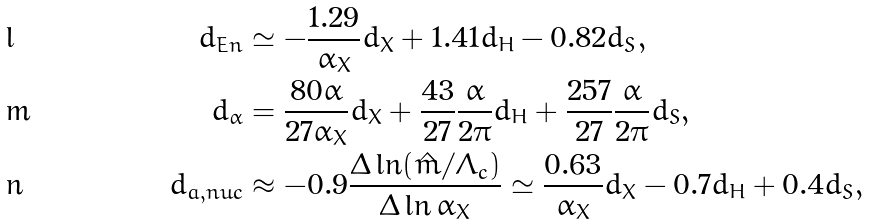<formula> <loc_0><loc_0><loc_500><loc_500>d _ { E n } & \simeq - \frac { 1 . 2 9 } { \alpha _ { X } } d _ { X } + 1 . 4 1 d _ { H } - 0 . 8 2 d _ { S } , \\ d _ { \alpha } & = \frac { 8 0 \alpha } { 2 7 \alpha _ { X } } d _ { X } + \frac { 4 3 } { 2 7 } \frac { \alpha } { 2 \pi } d _ { H } + \frac { 2 5 7 } { 2 7 } \frac { \alpha } { 2 \pi } d _ { S } , \\ d _ { a , n u c } & \approx - 0 . 9 \frac { \Delta \ln ( \hat { m } / \Lambda _ { c } ) } { \Delta \ln \alpha _ { X } } \simeq \frac { 0 . 6 3 } { \alpha _ { X } } d _ { X } - 0 . 7 d _ { H } + 0 . 4 d _ { S } ,</formula> 